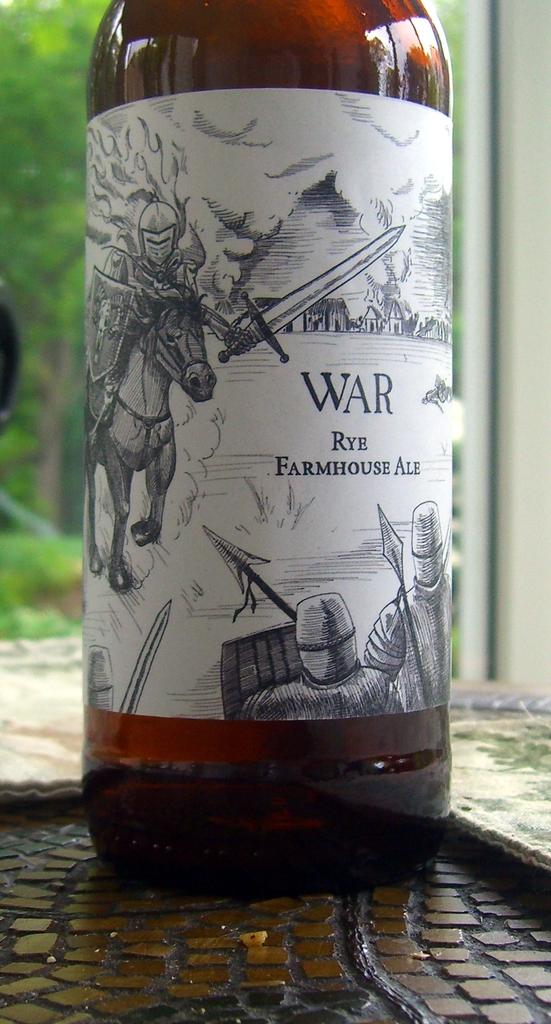What kind of wine is this?
Ensure brevity in your answer.  War rye farmhouse ale. Is rye farmhouse ale a brand of beer?
Provide a succinct answer. Yes. 